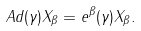Convert formula to latex. <formula><loc_0><loc_0><loc_500><loc_500>\ A d ( \gamma ) X _ { \beta } = e ^ { \beta } ( \gamma ) X _ { \beta } .</formula> 